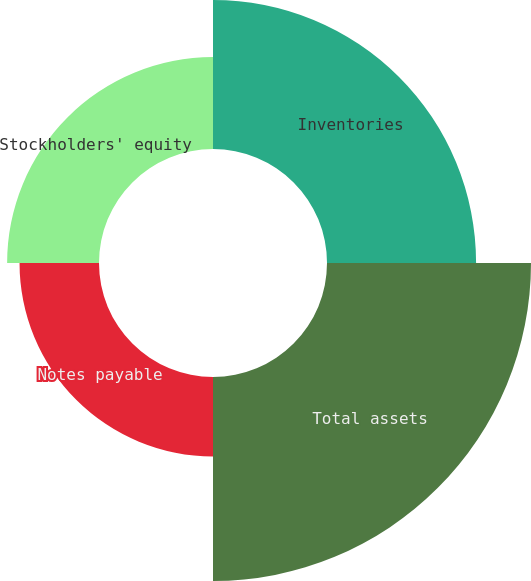Convert chart to OTSL. <chart><loc_0><loc_0><loc_500><loc_500><pie_chart><fcel>Inventories<fcel>Total assets<fcel>Notes payable<fcel>Stockholders' equity<nl><fcel>28.43%<fcel>38.9%<fcel>15.15%<fcel>17.52%<nl></chart> 